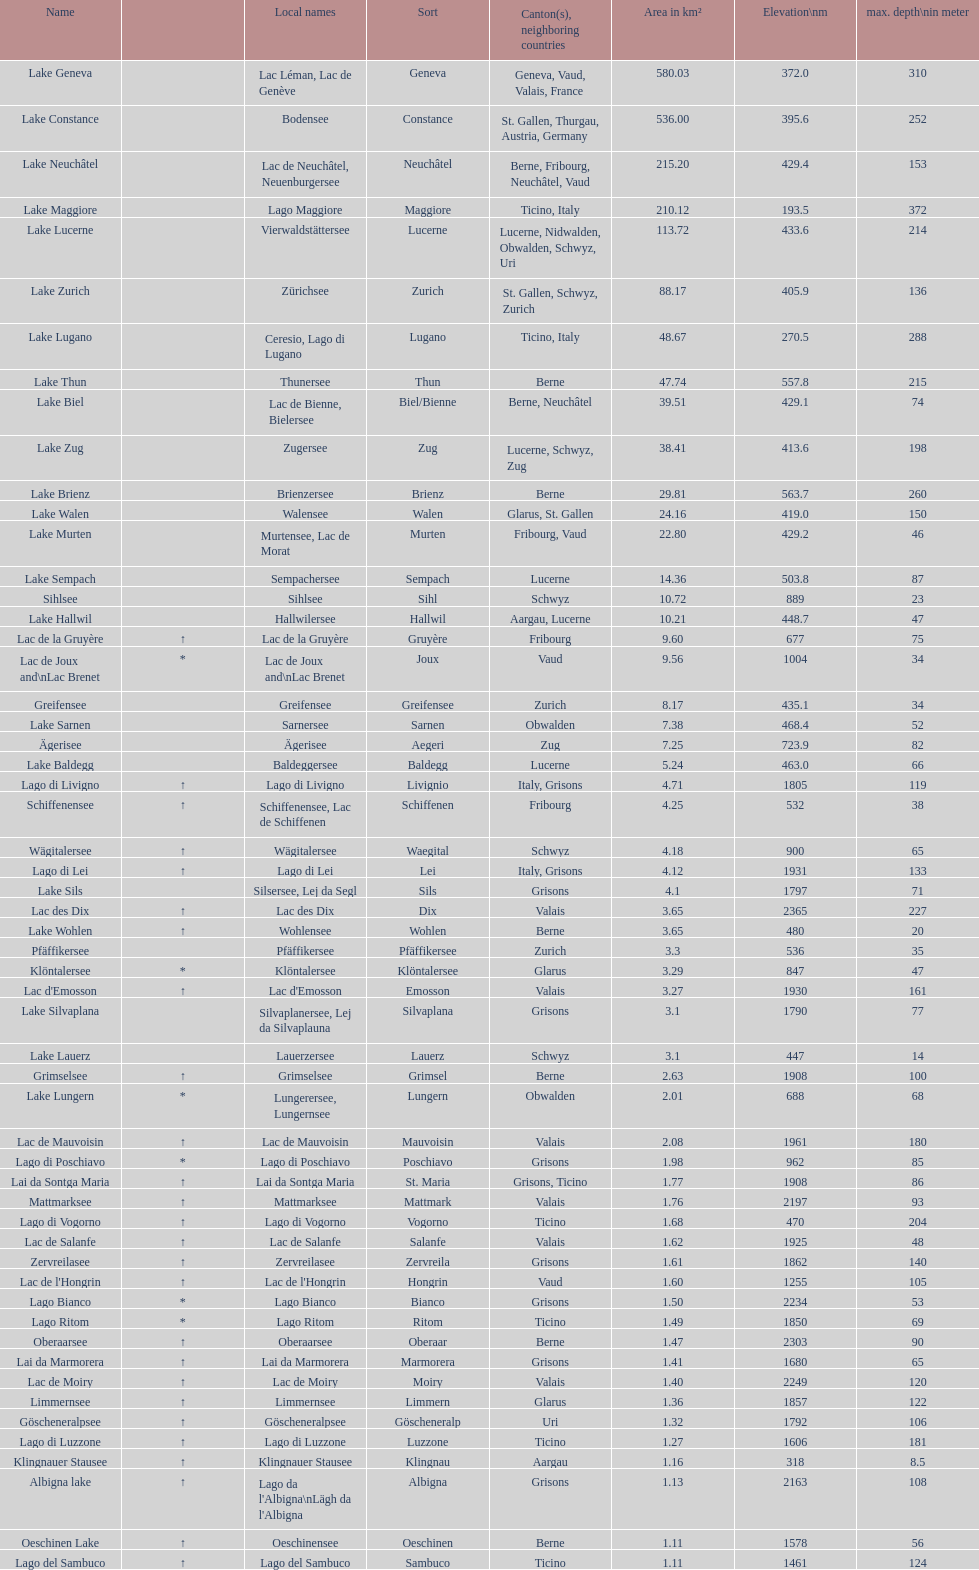Which lake is smaller in area km²? albigna lake or oeschinen lake? Oeschinen Lake. 